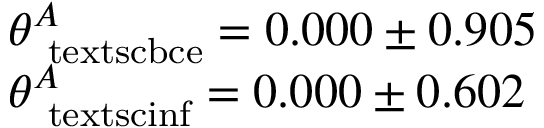<formula> <loc_0><loc_0><loc_500><loc_500>\begin{array} { l l } { \theta _ { \ t e x t s c { b c e } } ^ { A } = 0 . 0 0 0 \pm 0 . 9 0 5 } \\ { \theta _ { \ t e x t s c { i n f } } ^ { A } = 0 . 0 0 0 \pm 0 . 6 0 2 } \end{array}</formula> 